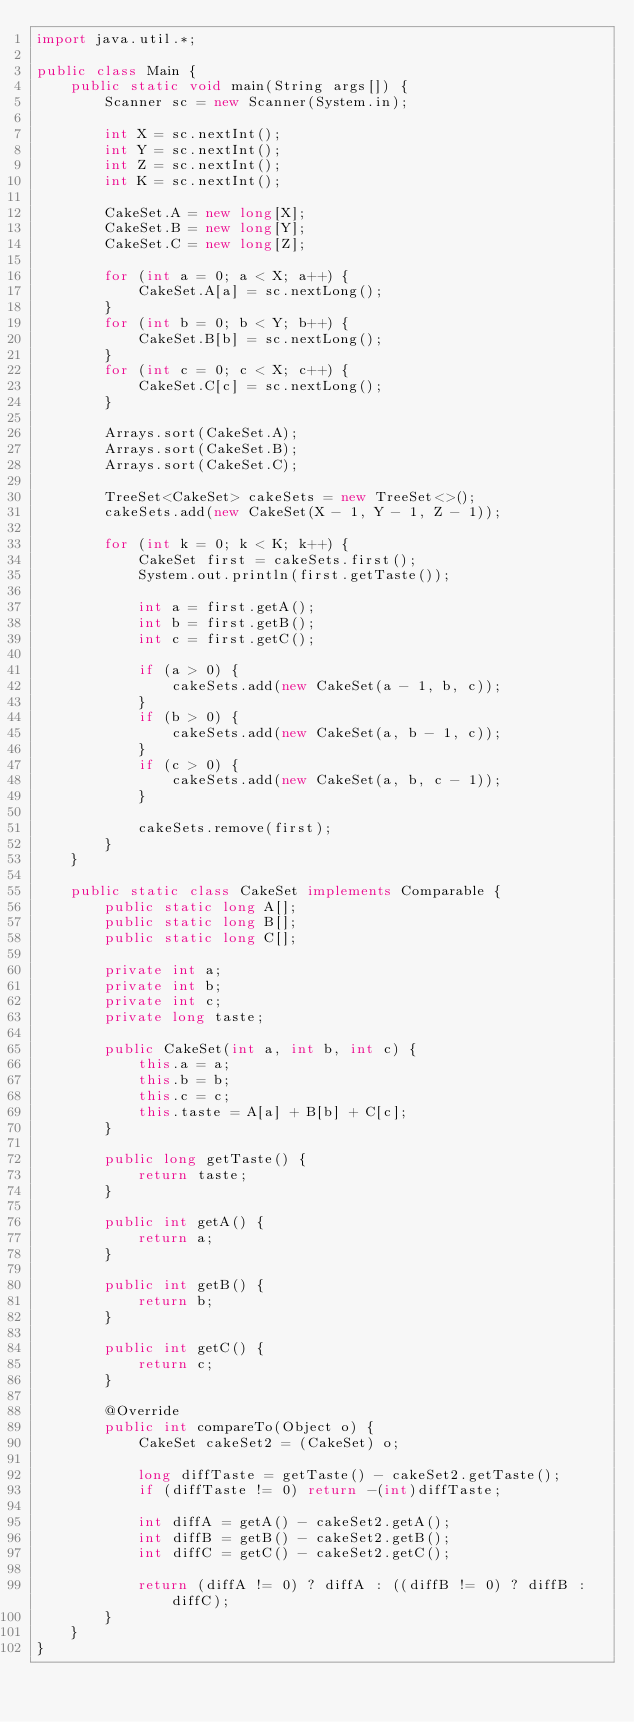<code> <loc_0><loc_0><loc_500><loc_500><_Java_>import java.util.*;

public class Main {
    public static void main(String args[]) {
        Scanner sc = new Scanner(System.in);

        int X = sc.nextInt();
        int Y = sc.nextInt();
        int Z = sc.nextInt();
        int K = sc.nextInt();

        CakeSet.A = new long[X];
        CakeSet.B = new long[Y];
        CakeSet.C = new long[Z];

        for (int a = 0; a < X; a++) {
            CakeSet.A[a] = sc.nextLong();
        }
        for (int b = 0; b < Y; b++) {
            CakeSet.B[b] = sc.nextLong();
        }
        for (int c = 0; c < X; c++) {
            CakeSet.C[c] = sc.nextLong();
        }

        Arrays.sort(CakeSet.A);
        Arrays.sort(CakeSet.B);
        Arrays.sort(CakeSet.C);

        TreeSet<CakeSet> cakeSets = new TreeSet<>();
        cakeSets.add(new CakeSet(X - 1, Y - 1, Z - 1));

        for (int k = 0; k < K; k++) {
            CakeSet first = cakeSets.first();
            System.out.println(first.getTaste());

            int a = first.getA();
            int b = first.getB();
            int c = first.getC();

            if (a > 0) {
                cakeSets.add(new CakeSet(a - 1, b, c));
            }
            if (b > 0) {
                cakeSets.add(new CakeSet(a, b - 1, c));
            }
            if (c > 0) {
                cakeSets.add(new CakeSet(a, b, c - 1));
            }

            cakeSets.remove(first);
        }
    }

    public static class CakeSet implements Comparable {
        public static long A[];
        public static long B[];
        public static long C[];

        private int a;
        private int b;
        private int c;
        private long taste;

        public CakeSet(int a, int b, int c) {
            this.a = a;
            this.b = b;
            this.c = c;
            this.taste = A[a] + B[b] + C[c];
        }

        public long getTaste() {
            return taste;
        }

        public int getA() {
            return a;
        }

        public int getB() {
            return b;
        }

        public int getC() {
            return c;
        }

        @Override
        public int compareTo(Object o) {
            CakeSet cakeSet2 = (CakeSet) o;

            long diffTaste = getTaste() - cakeSet2.getTaste();
            if (diffTaste != 0) return -(int)diffTaste;

            int diffA = getA() - cakeSet2.getA();
            int diffB = getB() - cakeSet2.getB();
            int diffC = getC() - cakeSet2.getC();

            return (diffA != 0) ? diffA : ((diffB != 0) ? diffB : diffC);
        }
    }
}
</code> 